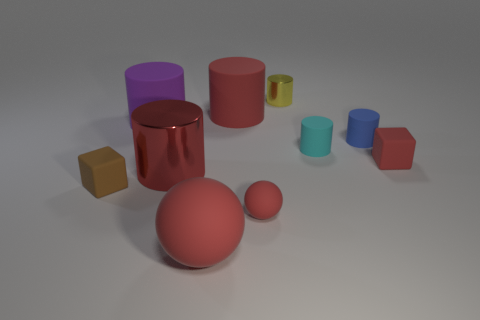Subtract all red matte cylinders. How many cylinders are left? 5 Subtract all gray balls. How many red cylinders are left? 2 Subtract all purple cylinders. How many cylinders are left? 5 Subtract 4 cylinders. How many cylinders are left? 2 Subtract all cubes. How many objects are left? 8 Subtract all green balls. Subtract all brown blocks. How many balls are left? 2 Subtract 0 blue cubes. How many objects are left? 10 Subtract all tiny red things. Subtract all small shiny things. How many objects are left? 7 Add 2 red rubber spheres. How many red rubber spheres are left? 4 Add 3 purple blocks. How many purple blocks exist? 3 